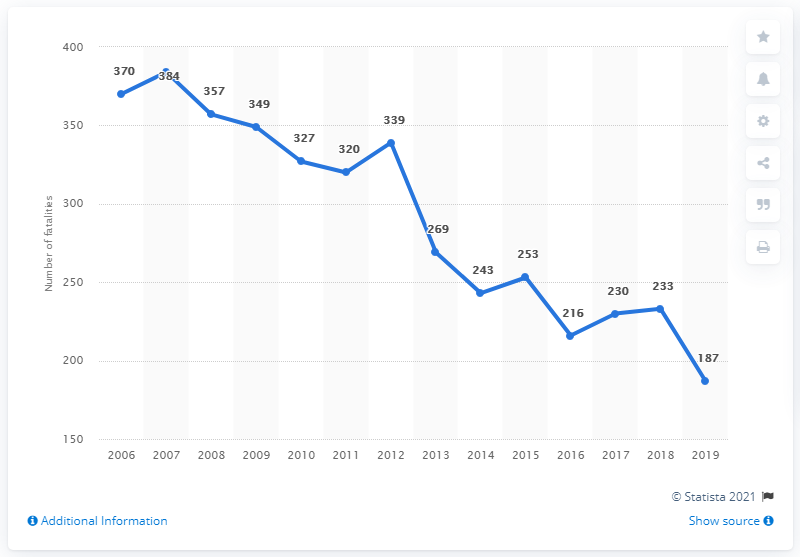List a handful of essential elements in this visual. The number of road traffic fatalities in Switzerland between the years 2018 and 2019 was 46. In 2019, a total of 187 fatalities were recorded on Swiss roads. In the year 2012, there were 339 fatalities due to road traffic accidents in Switzerland. 